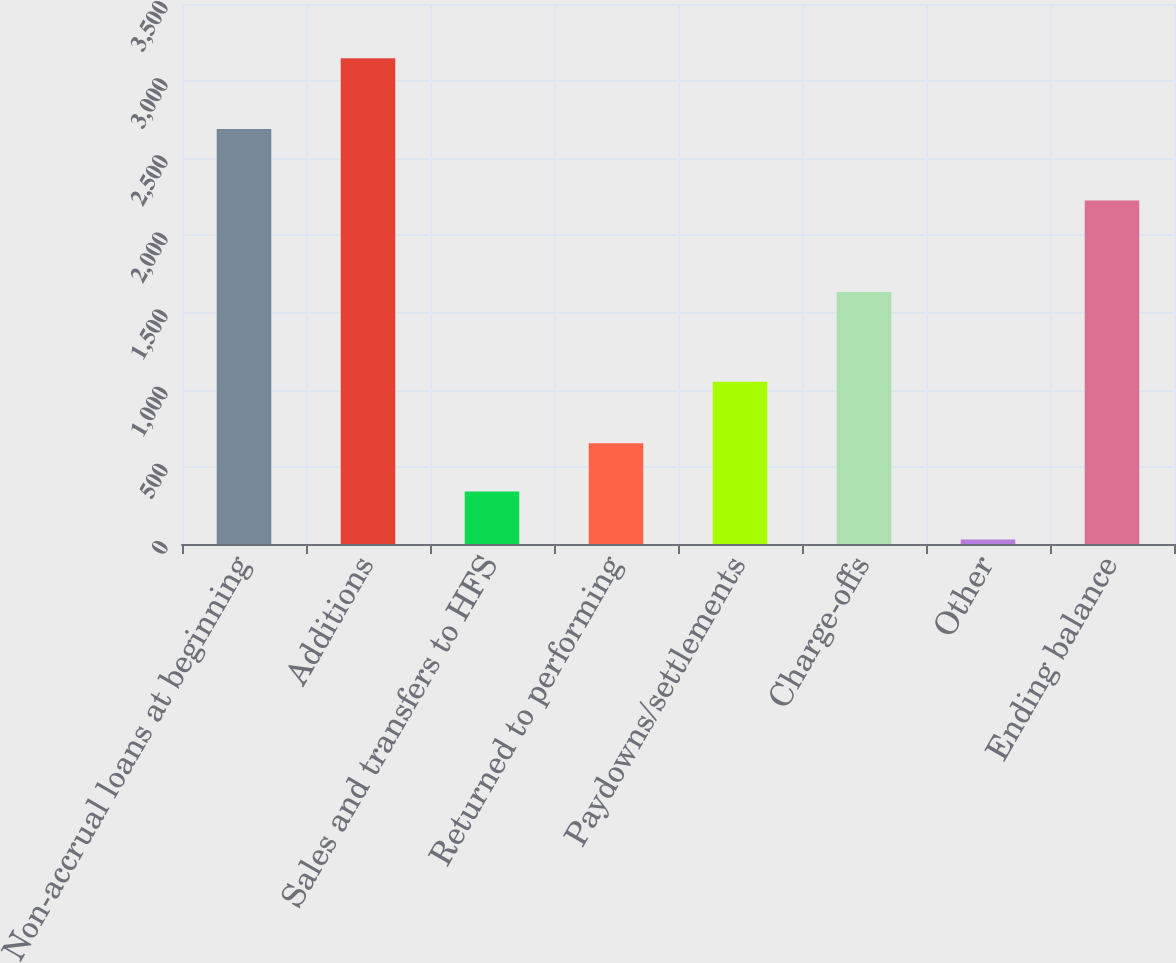Convert chart to OTSL. <chart><loc_0><loc_0><loc_500><loc_500><bar_chart><fcel>Non-accrual loans at beginning<fcel>Additions<fcel>Sales and transfers to HFS<fcel>Returned to performing<fcel>Paydowns/settlements<fcel>Charge-offs<fcel>Other<fcel>Ending balance<nl><fcel>2690<fcel>3148<fcel>340.9<fcel>652.8<fcel>1052<fcel>1634<fcel>29<fcel>2226<nl></chart> 